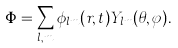Convert formula to latex. <formula><loc_0><loc_0><loc_500><loc_500>\Phi = \sum _ { l , m } \phi _ { l m } ( r , t ) Y _ { l m } ( \theta , \varphi ) .</formula> 